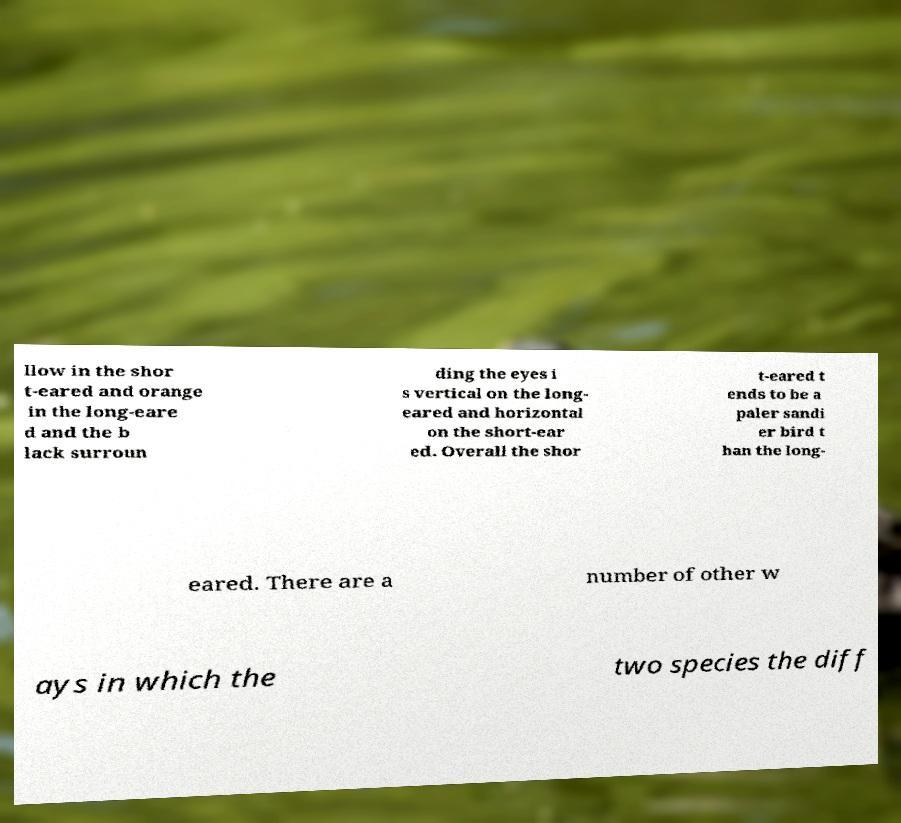Please identify and transcribe the text found in this image. llow in the shor t-eared and orange in the long-eare d and the b lack surroun ding the eyes i s vertical on the long- eared and horizontal on the short-ear ed. Overall the shor t-eared t ends to be a paler sandi er bird t han the long- eared. There are a number of other w ays in which the two species the diff 